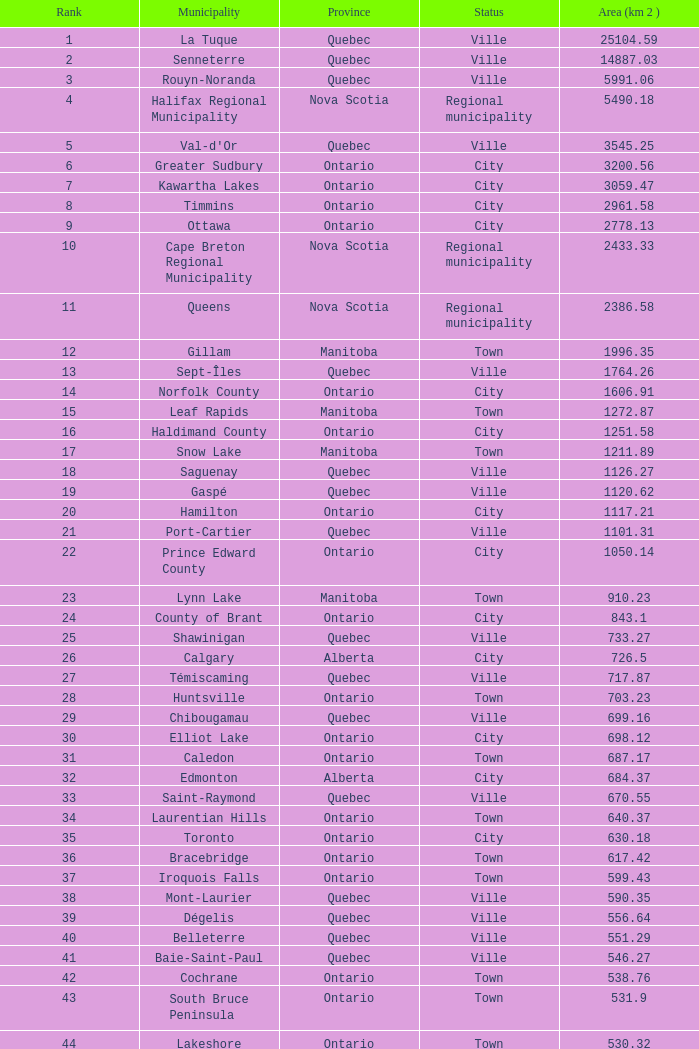What is the cumulative rank for an area measuring 1050.14 km 2? 22.0. 